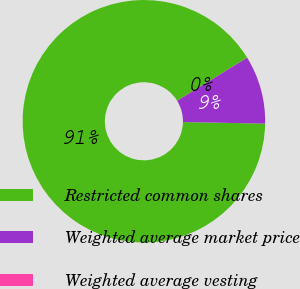<chart> <loc_0><loc_0><loc_500><loc_500><pie_chart><fcel>Restricted common shares<fcel>Weighted average market price<fcel>Weighted average vesting<nl><fcel>90.9%<fcel>9.09%<fcel>0.01%<nl></chart> 